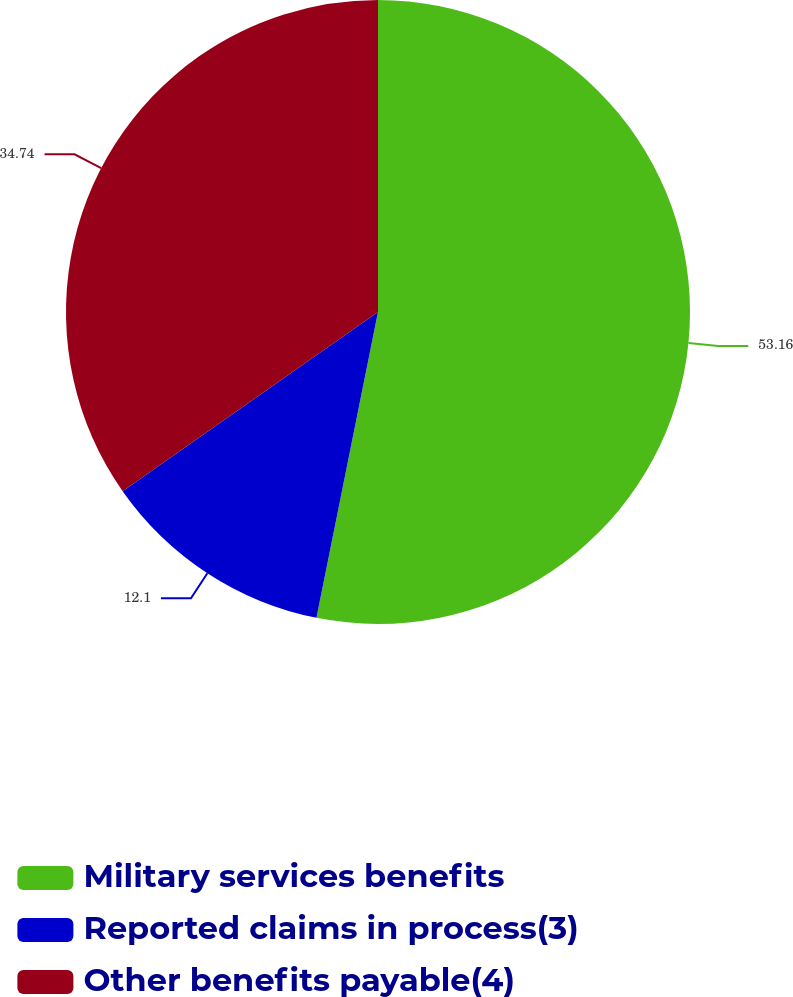Convert chart to OTSL. <chart><loc_0><loc_0><loc_500><loc_500><pie_chart><fcel>Military services benefits<fcel>Reported claims in process(3)<fcel>Other benefits payable(4)<nl><fcel>53.16%<fcel>12.1%<fcel>34.74%<nl></chart> 